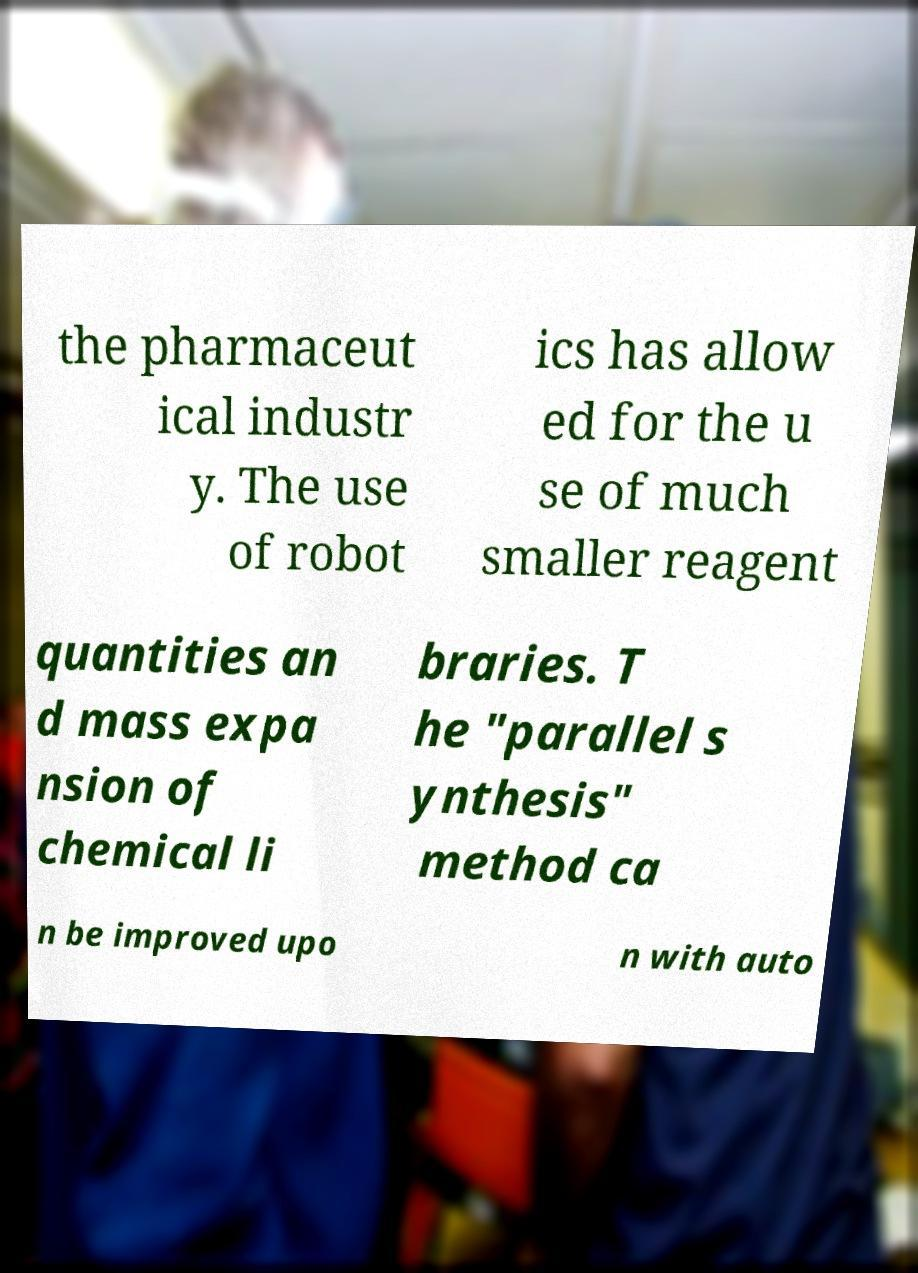Can you read and provide the text displayed in the image?This photo seems to have some interesting text. Can you extract and type it out for me? the pharmaceut ical industr y. The use of robot ics has allow ed for the u se of much smaller reagent quantities an d mass expa nsion of chemical li braries. T he "parallel s ynthesis" method ca n be improved upo n with auto 